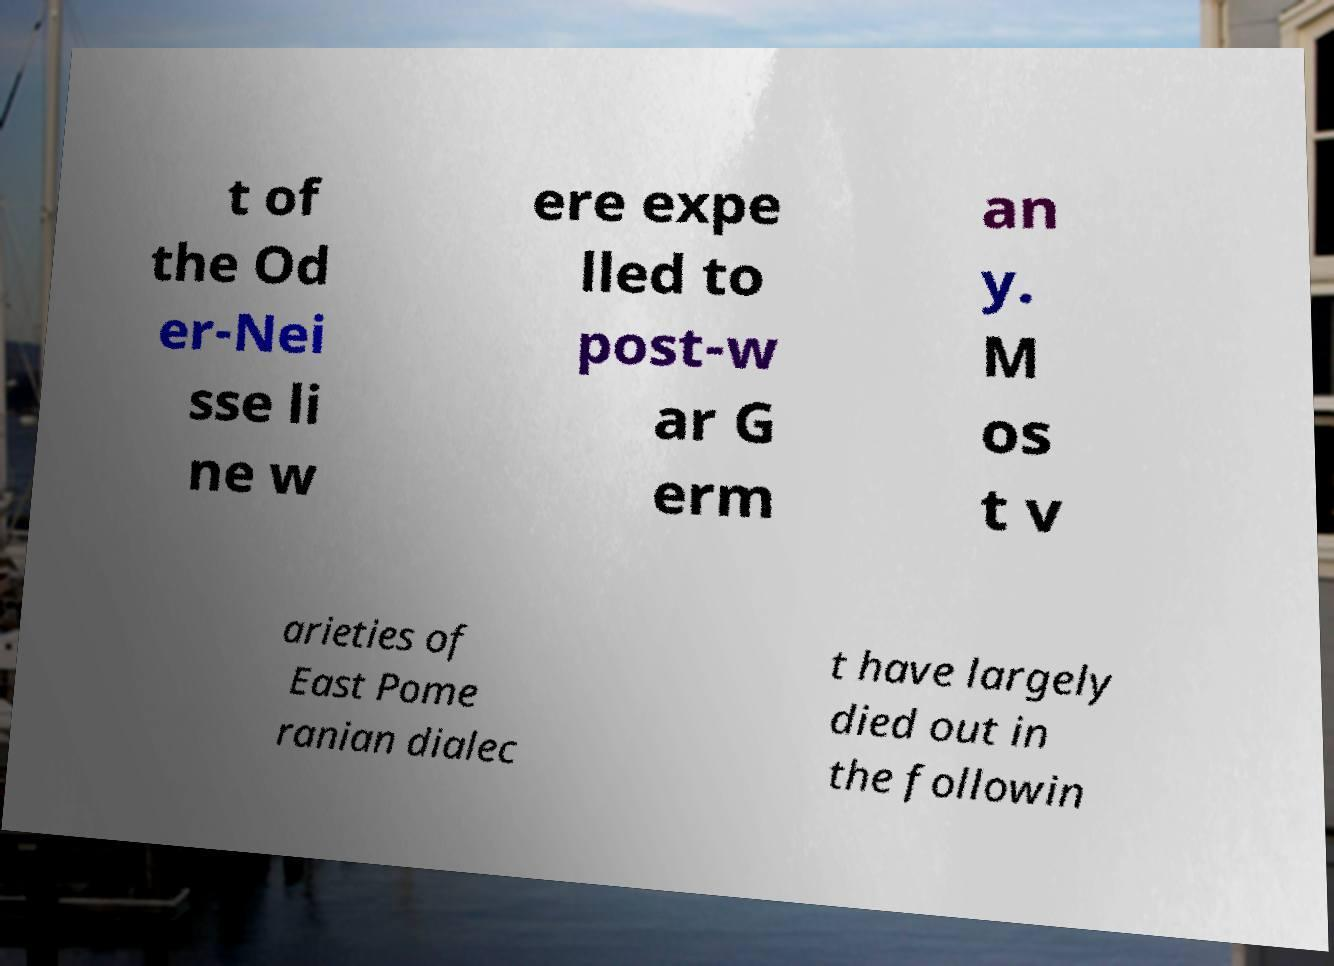Could you assist in decoding the text presented in this image and type it out clearly? t of the Od er-Nei sse li ne w ere expe lled to post-w ar G erm an y. M os t v arieties of East Pome ranian dialec t have largely died out in the followin 